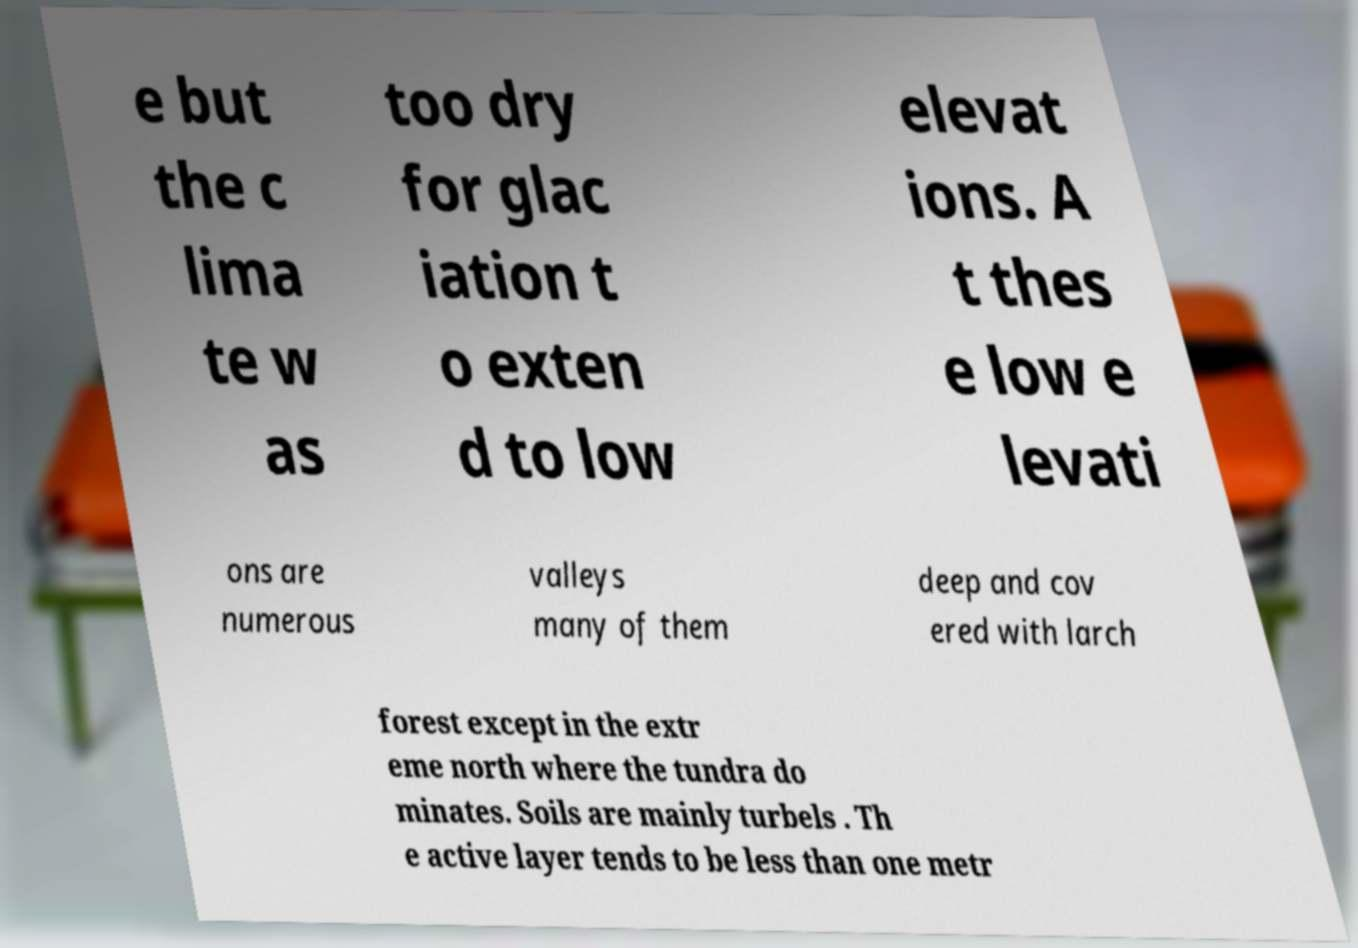Can you accurately transcribe the text from the provided image for me? e but the c lima te w as too dry for glac iation t o exten d to low elevat ions. A t thes e low e levati ons are numerous valleys many of them deep and cov ered with larch forest except in the extr eme north where the tundra do minates. Soils are mainly turbels . Th e active layer tends to be less than one metr 